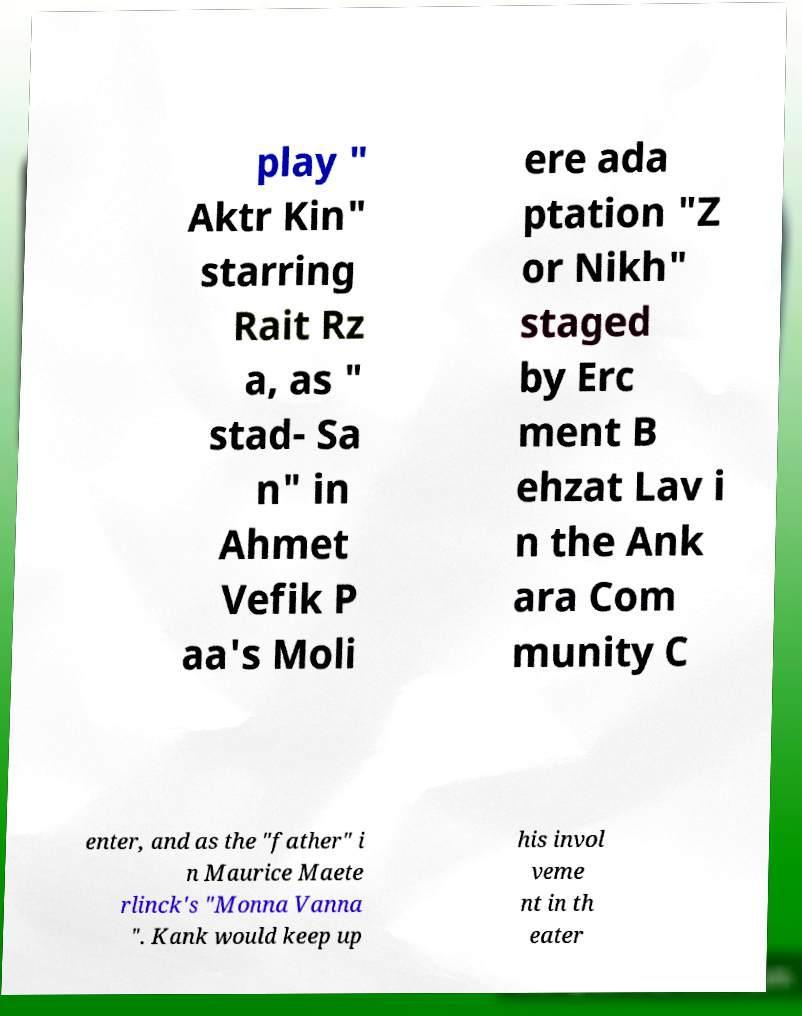Please identify and transcribe the text found in this image. play " Aktr Kin" starring Rait Rz a, as " stad- Sa n" in Ahmet Vefik P aa's Moli ere ada ptation "Z or Nikh" staged by Erc ment B ehzat Lav i n the Ank ara Com munity C enter, and as the "father" i n Maurice Maete rlinck's "Monna Vanna ". Kank would keep up his invol veme nt in th eater 